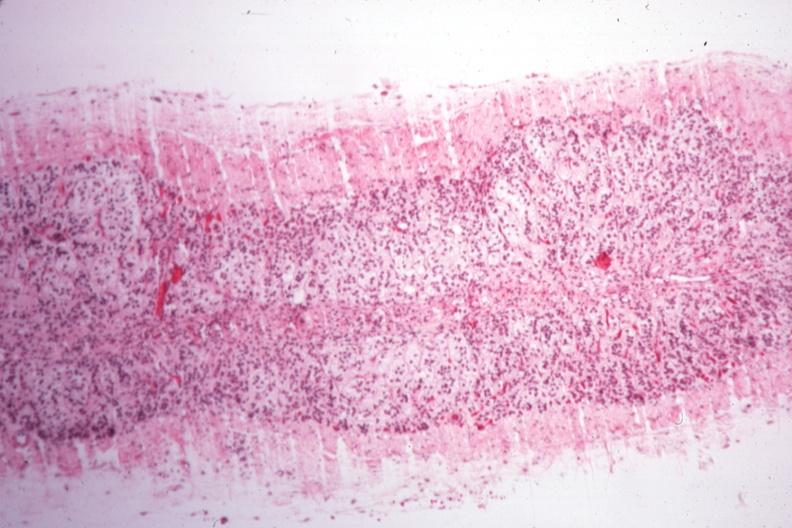what is present?
Answer the question using a single word or phrase. Atrophy secondary to pituitectomy 